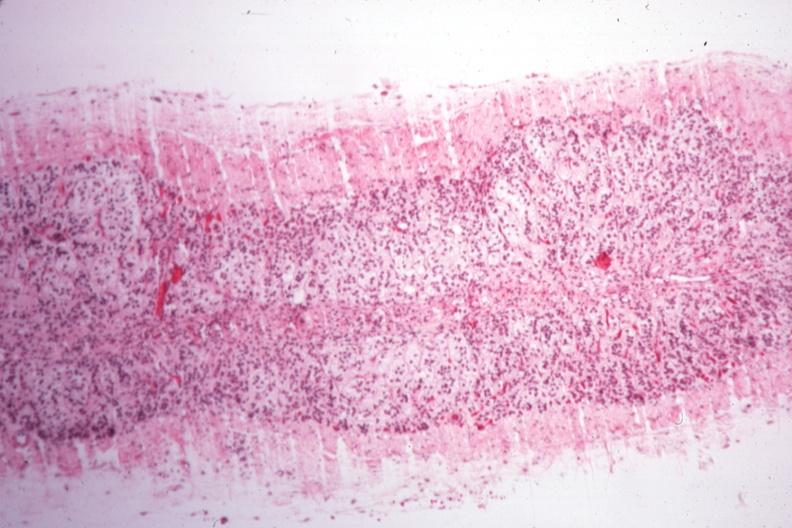what is present?
Answer the question using a single word or phrase. Atrophy secondary to pituitectomy 